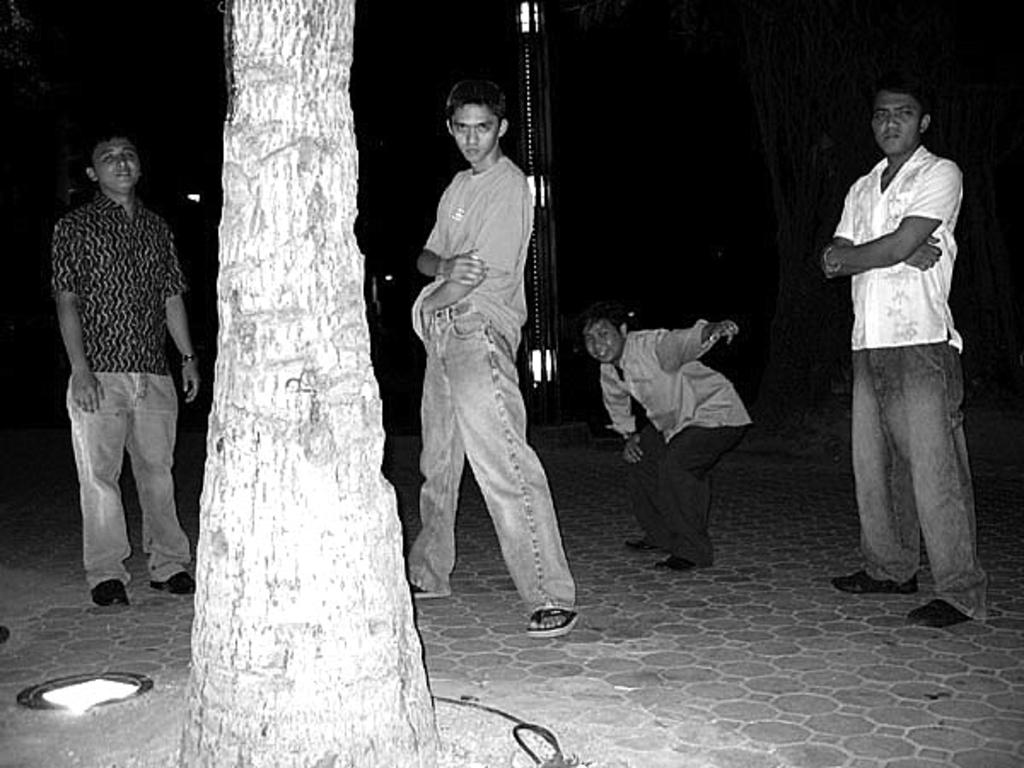What is the main object in the image? There is a trunk of a tree in the image. What else can be seen in the image besides the tree trunk? There are lights and people in the image. Can you describe the location of the light in the image? There is a light in the left corner bottom of the image. What type of underwear is the person wearing in the image? There is no information about the person's clothing in the image, so it cannot be determined what type of underwear they might be wearing. 